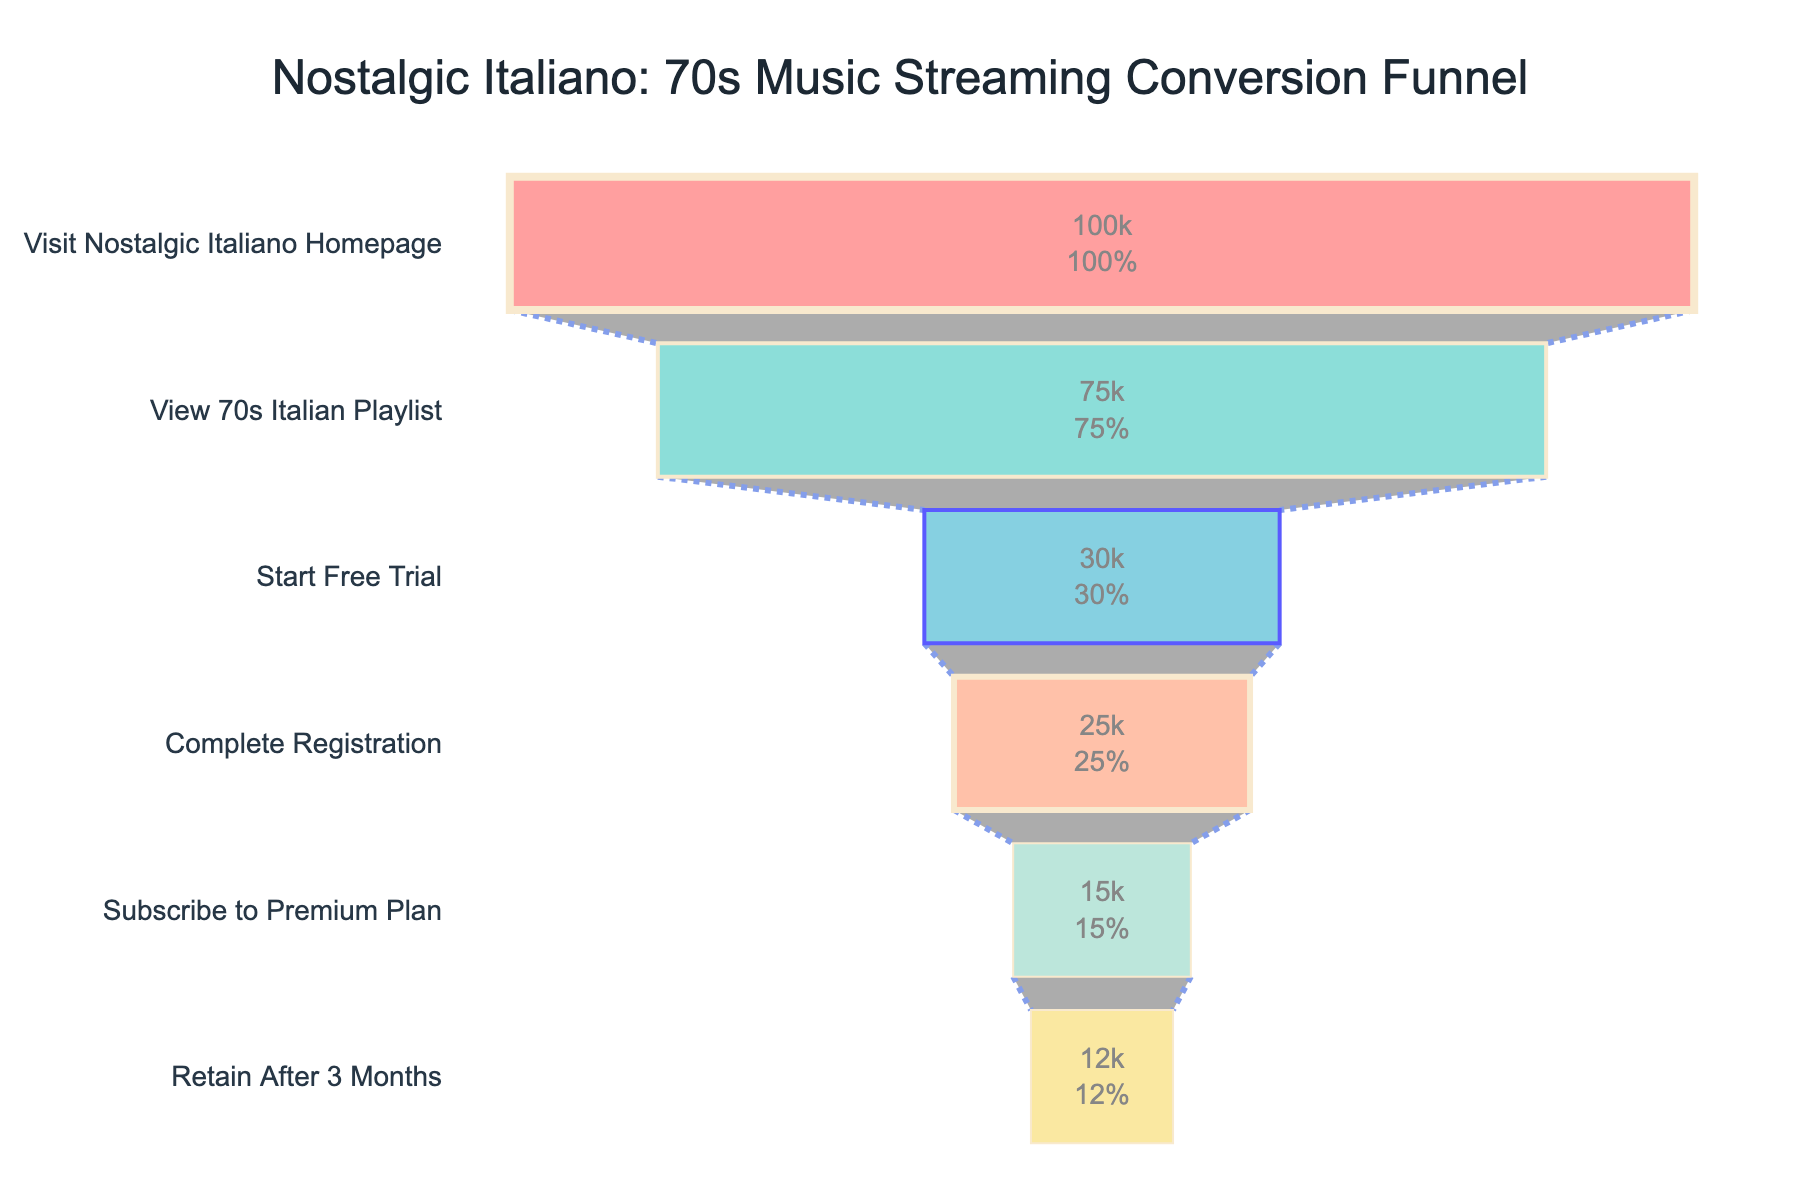What is the title of the funnel chart? The title is at the top of the figure and reads "Nostalgic Italiano: 70s Music Streaming Conversion Funnel".
Answer: Nostalgic Italiano: 70s Music Streaming Conversion Funnel What stage has the highest number of users? The first stage, "Visit Nostalgic Italiano Homepage," has the highest number of users with 100,000. This is visually represented by the widest segment at the top of the funnel chart.
Answer: Visit Nostalgic Italiano Homepage How many users View the 70s Italian Playlist? The second stage, "View 70s Italian Playlist," shows 75,000 users, which can be found on the segment's label and visually compared to other stages in the funnel.
Answer: 75000 What percentage of users complete the registration process? The segment for "Complete Registration" shows 25,000 users, and the percentage listed is 25%.
Answer: 25% How many users continue to subscribe to the premium plan after completing registration? The difference in users between "Complete Registration" (25,000) and "Subscribe to Premium Plan" (15,000) indicates that 10,000 users do not continue to subscribe to the premium plan.
Answer: 10000 Which stage has the second-highest drop-off in the number of users? The drop-off can be seen in the changes in user numbers between adjacent stages. The second-highest drop-off is between "Start Free Trial" (30,000) and "Complete Registration" (25,000), which shows a loss of 5,000 users.
Answer: Between Start Free Trial and Complete Registration What is the final percentage of users retained after three months? The segment for "Retain After 3 Months" at the bottom of the funnel shows a percentage of 12%.
Answer: 12% Comparing "Start Free Trial" and "Subscribe to Premium Plan," by how many users does the number decrease? "Start Free Trial" has 30,000 users, and "Subscribe to Premium Plan" has 15,000 users. The decrease is 30,000 - 15,000 = 15,000 users.
Answer: 15000 What are the colors used in the funnel chart? The segments are colored as follows: #FF6B6B, #4ECDC4, #45B7D1, #FFA07A, #98D8C8, #F7DC6F. These can be described as shades of red, green, blue, orange, light green, and yellow.
Answer: Red, green, blue, orange, light green, yellow How many users drop off after viewing the 70s Italian Playlist and before starting the free trial? The number of users viewing the playlist is 75,000, and starting the free trial is 30,000. The drop-off is 75,000 - 30,000 = 45,000 users.
Answer: 45000 